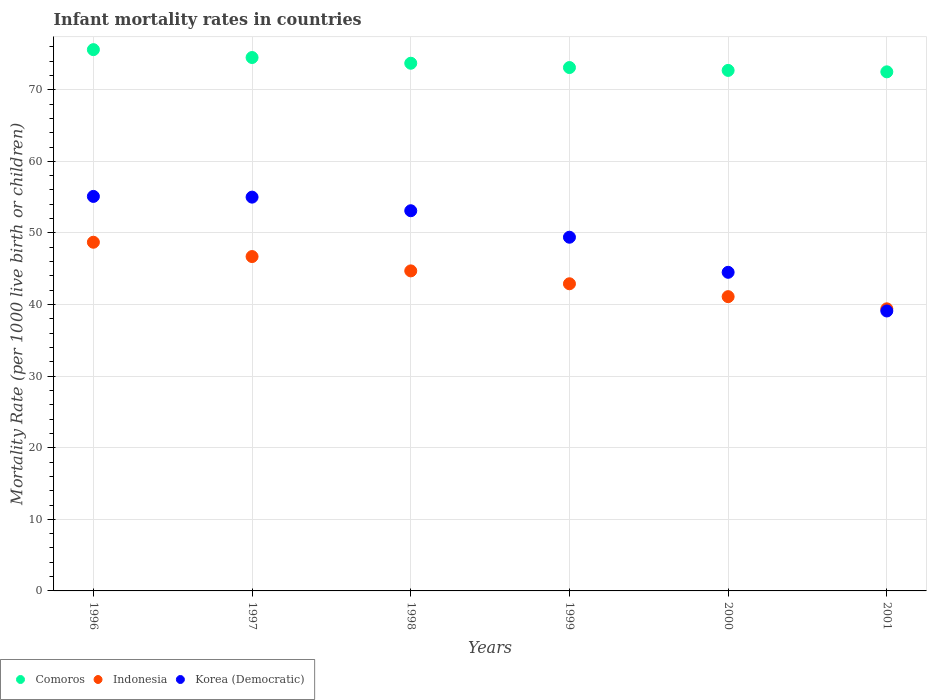What is the infant mortality rate in Korea (Democratic) in 1996?
Offer a very short reply. 55.1. Across all years, what is the maximum infant mortality rate in Korea (Democratic)?
Your answer should be compact. 55.1. Across all years, what is the minimum infant mortality rate in Comoros?
Give a very brief answer. 72.5. In which year was the infant mortality rate in Korea (Democratic) maximum?
Provide a succinct answer. 1996. In which year was the infant mortality rate in Comoros minimum?
Provide a succinct answer. 2001. What is the total infant mortality rate in Indonesia in the graph?
Give a very brief answer. 263.5. What is the difference between the infant mortality rate in Comoros in 1996 and that in 2001?
Your response must be concise. 3.1. What is the difference between the infant mortality rate in Korea (Democratic) in 1998 and the infant mortality rate in Indonesia in 2001?
Offer a terse response. 13.7. What is the average infant mortality rate in Comoros per year?
Provide a short and direct response. 73.68. In the year 1996, what is the difference between the infant mortality rate in Comoros and infant mortality rate in Indonesia?
Ensure brevity in your answer.  26.9. In how many years, is the infant mortality rate in Korea (Democratic) greater than 42?
Provide a succinct answer. 5. What is the ratio of the infant mortality rate in Indonesia in 1996 to that in 2000?
Provide a short and direct response. 1.18. Is the difference between the infant mortality rate in Comoros in 1998 and 2000 greater than the difference between the infant mortality rate in Indonesia in 1998 and 2000?
Offer a very short reply. No. What is the difference between the highest and the second highest infant mortality rate in Comoros?
Your answer should be compact. 1.1. What is the difference between the highest and the lowest infant mortality rate in Korea (Democratic)?
Offer a very short reply. 16. Is it the case that in every year, the sum of the infant mortality rate in Indonesia and infant mortality rate in Korea (Democratic)  is greater than the infant mortality rate in Comoros?
Keep it short and to the point. Yes. Does the infant mortality rate in Korea (Democratic) monotonically increase over the years?
Ensure brevity in your answer.  No. Is the infant mortality rate in Indonesia strictly greater than the infant mortality rate in Comoros over the years?
Provide a short and direct response. No. How many dotlines are there?
Offer a terse response. 3. Does the graph contain grids?
Your response must be concise. Yes. Where does the legend appear in the graph?
Provide a succinct answer. Bottom left. How many legend labels are there?
Give a very brief answer. 3. How are the legend labels stacked?
Provide a succinct answer. Horizontal. What is the title of the graph?
Give a very brief answer. Infant mortality rates in countries. What is the label or title of the X-axis?
Your answer should be compact. Years. What is the label or title of the Y-axis?
Offer a very short reply. Mortality Rate (per 1000 live birth or children). What is the Mortality Rate (per 1000 live birth or children) of Comoros in 1996?
Offer a terse response. 75.6. What is the Mortality Rate (per 1000 live birth or children) of Indonesia in 1996?
Ensure brevity in your answer.  48.7. What is the Mortality Rate (per 1000 live birth or children) of Korea (Democratic) in 1996?
Provide a succinct answer. 55.1. What is the Mortality Rate (per 1000 live birth or children) in Comoros in 1997?
Offer a terse response. 74.5. What is the Mortality Rate (per 1000 live birth or children) in Indonesia in 1997?
Provide a succinct answer. 46.7. What is the Mortality Rate (per 1000 live birth or children) in Comoros in 1998?
Offer a terse response. 73.7. What is the Mortality Rate (per 1000 live birth or children) of Indonesia in 1998?
Your answer should be compact. 44.7. What is the Mortality Rate (per 1000 live birth or children) of Korea (Democratic) in 1998?
Offer a very short reply. 53.1. What is the Mortality Rate (per 1000 live birth or children) of Comoros in 1999?
Provide a short and direct response. 73.1. What is the Mortality Rate (per 1000 live birth or children) of Indonesia in 1999?
Provide a short and direct response. 42.9. What is the Mortality Rate (per 1000 live birth or children) in Korea (Democratic) in 1999?
Give a very brief answer. 49.4. What is the Mortality Rate (per 1000 live birth or children) of Comoros in 2000?
Provide a short and direct response. 72.7. What is the Mortality Rate (per 1000 live birth or children) of Indonesia in 2000?
Your answer should be compact. 41.1. What is the Mortality Rate (per 1000 live birth or children) in Korea (Democratic) in 2000?
Your response must be concise. 44.5. What is the Mortality Rate (per 1000 live birth or children) in Comoros in 2001?
Keep it short and to the point. 72.5. What is the Mortality Rate (per 1000 live birth or children) in Indonesia in 2001?
Provide a short and direct response. 39.4. What is the Mortality Rate (per 1000 live birth or children) in Korea (Democratic) in 2001?
Make the answer very short. 39.1. Across all years, what is the maximum Mortality Rate (per 1000 live birth or children) in Comoros?
Provide a succinct answer. 75.6. Across all years, what is the maximum Mortality Rate (per 1000 live birth or children) in Indonesia?
Your response must be concise. 48.7. Across all years, what is the maximum Mortality Rate (per 1000 live birth or children) in Korea (Democratic)?
Keep it short and to the point. 55.1. Across all years, what is the minimum Mortality Rate (per 1000 live birth or children) in Comoros?
Keep it short and to the point. 72.5. Across all years, what is the minimum Mortality Rate (per 1000 live birth or children) in Indonesia?
Offer a terse response. 39.4. Across all years, what is the minimum Mortality Rate (per 1000 live birth or children) in Korea (Democratic)?
Offer a terse response. 39.1. What is the total Mortality Rate (per 1000 live birth or children) of Comoros in the graph?
Your answer should be very brief. 442.1. What is the total Mortality Rate (per 1000 live birth or children) in Indonesia in the graph?
Ensure brevity in your answer.  263.5. What is the total Mortality Rate (per 1000 live birth or children) in Korea (Democratic) in the graph?
Offer a very short reply. 296.2. What is the difference between the Mortality Rate (per 1000 live birth or children) of Indonesia in 1996 and that in 1997?
Make the answer very short. 2. What is the difference between the Mortality Rate (per 1000 live birth or children) in Comoros in 1996 and that in 1998?
Give a very brief answer. 1.9. What is the difference between the Mortality Rate (per 1000 live birth or children) of Indonesia in 1996 and that in 1999?
Offer a terse response. 5.8. What is the difference between the Mortality Rate (per 1000 live birth or children) of Comoros in 1996 and that in 2001?
Your response must be concise. 3.1. What is the difference between the Mortality Rate (per 1000 live birth or children) of Indonesia in 1996 and that in 2001?
Ensure brevity in your answer.  9.3. What is the difference between the Mortality Rate (per 1000 live birth or children) in Korea (Democratic) in 1996 and that in 2001?
Ensure brevity in your answer.  16. What is the difference between the Mortality Rate (per 1000 live birth or children) in Indonesia in 1997 and that in 1998?
Your answer should be compact. 2. What is the difference between the Mortality Rate (per 1000 live birth or children) in Korea (Democratic) in 1997 and that in 1998?
Your answer should be very brief. 1.9. What is the difference between the Mortality Rate (per 1000 live birth or children) of Comoros in 1997 and that in 1999?
Offer a very short reply. 1.4. What is the difference between the Mortality Rate (per 1000 live birth or children) in Indonesia in 1997 and that in 1999?
Offer a terse response. 3.8. What is the difference between the Mortality Rate (per 1000 live birth or children) of Comoros in 1997 and that in 2000?
Provide a succinct answer. 1.8. What is the difference between the Mortality Rate (per 1000 live birth or children) of Korea (Democratic) in 1997 and that in 2000?
Make the answer very short. 10.5. What is the difference between the Mortality Rate (per 1000 live birth or children) in Korea (Democratic) in 1997 and that in 2001?
Offer a terse response. 15.9. What is the difference between the Mortality Rate (per 1000 live birth or children) of Comoros in 1998 and that in 2000?
Provide a short and direct response. 1. What is the difference between the Mortality Rate (per 1000 live birth or children) in Indonesia in 1998 and that in 2000?
Provide a short and direct response. 3.6. What is the difference between the Mortality Rate (per 1000 live birth or children) of Korea (Democratic) in 1998 and that in 2000?
Your answer should be very brief. 8.6. What is the difference between the Mortality Rate (per 1000 live birth or children) in Indonesia in 1998 and that in 2001?
Ensure brevity in your answer.  5.3. What is the difference between the Mortality Rate (per 1000 live birth or children) in Comoros in 1999 and that in 2000?
Your response must be concise. 0.4. What is the difference between the Mortality Rate (per 1000 live birth or children) of Comoros in 1999 and that in 2001?
Keep it short and to the point. 0.6. What is the difference between the Mortality Rate (per 1000 live birth or children) in Indonesia in 1999 and that in 2001?
Ensure brevity in your answer.  3.5. What is the difference between the Mortality Rate (per 1000 live birth or children) of Korea (Democratic) in 1999 and that in 2001?
Make the answer very short. 10.3. What is the difference between the Mortality Rate (per 1000 live birth or children) of Comoros in 1996 and the Mortality Rate (per 1000 live birth or children) of Indonesia in 1997?
Keep it short and to the point. 28.9. What is the difference between the Mortality Rate (per 1000 live birth or children) of Comoros in 1996 and the Mortality Rate (per 1000 live birth or children) of Korea (Democratic) in 1997?
Offer a terse response. 20.6. What is the difference between the Mortality Rate (per 1000 live birth or children) in Indonesia in 1996 and the Mortality Rate (per 1000 live birth or children) in Korea (Democratic) in 1997?
Your answer should be very brief. -6.3. What is the difference between the Mortality Rate (per 1000 live birth or children) of Comoros in 1996 and the Mortality Rate (per 1000 live birth or children) of Indonesia in 1998?
Your answer should be very brief. 30.9. What is the difference between the Mortality Rate (per 1000 live birth or children) in Comoros in 1996 and the Mortality Rate (per 1000 live birth or children) in Korea (Democratic) in 1998?
Provide a short and direct response. 22.5. What is the difference between the Mortality Rate (per 1000 live birth or children) in Comoros in 1996 and the Mortality Rate (per 1000 live birth or children) in Indonesia in 1999?
Ensure brevity in your answer.  32.7. What is the difference between the Mortality Rate (per 1000 live birth or children) in Comoros in 1996 and the Mortality Rate (per 1000 live birth or children) in Korea (Democratic) in 1999?
Provide a succinct answer. 26.2. What is the difference between the Mortality Rate (per 1000 live birth or children) of Comoros in 1996 and the Mortality Rate (per 1000 live birth or children) of Indonesia in 2000?
Your answer should be very brief. 34.5. What is the difference between the Mortality Rate (per 1000 live birth or children) of Comoros in 1996 and the Mortality Rate (per 1000 live birth or children) of Korea (Democratic) in 2000?
Offer a very short reply. 31.1. What is the difference between the Mortality Rate (per 1000 live birth or children) in Indonesia in 1996 and the Mortality Rate (per 1000 live birth or children) in Korea (Democratic) in 2000?
Give a very brief answer. 4.2. What is the difference between the Mortality Rate (per 1000 live birth or children) of Comoros in 1996 and the Mortality Rate (per 1000 live birth or children) of Indonesia in 2001?
Make the answer very short. 36.2. What is the difference between the Mortality Rate (per 1000 live birth or children) of Comoros in 1996 and the Mortality Rate (per 1000 live birth or children) of Korea (Democratic) in 2001?
Ensure brevity in your answer.  36.5. What is the difference between the Mortality Rate (per 1000 live birth or children) of Indonesia in 1996 and the Mortality Rate (per 1000 live birth or children) of Korea (Democratic) in 2001?
Ensure brevity in your answer.  9.6. What is the difference between the Mortality Rate (per 1000 live birth or children) of Comoros in 1997 and the Mortality Rate (per 1000 live birth or children) of Indonesia in 1998?
Your answer should be compact. 29.8. What is the difference between the Mortality Rate (per 1000 live birth or children) of Comoros in 1997 and the Mortality Rate (per 1000 live birth or children) of Korea (Democratic) in 1998?
Give a very brief answer. 21.4. What is the difference between the Mortality Rate (per 1000 live birth or children) of Indonesia in 1997 and the Mortality Rate (per 1000 live birth or children) of Korea (Democratic) in 1998?
Provide a short and direct response. -6.4. What is the difference between the Mortality Rate (per 1000 live birth or children) in Comoros in 1997 and the Mortality Rate (per 1000 live birth or children) in Indonesia in 1999?
Ensure brevity in your answer.  31.6. What is the difference between the Mortality Rate (per 1000 live birth or children) of Comoros in 1997 and the Mortality Rate (per 1000 live birth or children) of Korea (Democratic) in 1999?
Provide a short and direct response. 25.1. What is the difference between the Mortality Rate (per 1000 live birth or children) of Comoros in 1997 and the Mortality Rate (per 1000 live birth or children) of Indonesia in 2000?
Make the answer very short. 33.4. What is the difference between the Mortality Rate (per 1000 live birth or children) of Comoros in 1997 and the Mortality Rate (per 1000 live birth or children) of Korea (Democratic) in 2000?
Your answer should be very brief. 30. What is the difference between the Mortality Rate (per 1000 live birth or children) in Comoros in 1997 and the Mortality Rate (per 1000 live birth or children) in Indonesia in 2001?
Your answer should be compact. 35.1. What is the difference between the Mortality Rate (per 1000 live birth or children) in Comoros in 1997 and the Mortality Rate (per 1000 live birth or children) in Korea (Democratic) in 2001?
Your answer should be very brief. 35.4. What is the difference between the Mortality Rate (per 1000 live birth or children) of Comoros in 1998 and the Mortality Rate (per 1000 live birth or children) of Indonesia in 1999?
Provide a short and direct response. 30.8. What is the difference between the Mortality Rate (per 1000 live birth or children) in Comoros in 1998 and the Mortality Rate (per 1000 live birth or children) in Korea (Democratic) in 1999?
Your response must be concise. 24.3. What is the difference between the Mortality Rate (per 1000 live birth or children) in Comoros in 1998 and the Mortality Rate (per 1000 live birth or children) in Indonesia in 2000?
Offer a terse response. 32.6. What is the difference between the Mortality Rate (per 1000 live birth or children) in Comoros in 1998 and the Mortality Rate (per 1000 live birth or children) in Korea (Democratic) in 2000?
Offer a very short reply. 29.2. What is the difference between the Mortality Rate (per 1000 live birth or children) of Comoros in 1998 and the Mortality Rate (per 1000 live birth or children) of Indonesia in 2001?
Your response must be concise. 34.3. What is the difference between the Mortality Rate (per 1000 live birth or children) in Comoros in 1998 and the Mortality Rate (per 1000 live birth or children) in Korea (Democratic) in 2001?
Give a very brief answer. 34.6. What is the difference between the Mortality Rate (per 1000 live birth or children) of Indonesia in 1998 and the Mortality Rate (per 1000 live birth or children) of Korea (Democratic) in 2001?
Offer a terse response. 5.6. What is the difference between the Mortality Rate (per 1000 live birth or children) of Comoros in 1999 and the Mortality Rate (per 1000 live birth or children) of Indonesia in 2000?
Give a very brief answer. 32. What is the difference between the Mortality Rate (per 1000 live birth or children) of Comoros in 1999 and the Mortality Rate (per 1000 live birth or children) of Korea (Democratic) in 2000?
Provide a short and direct response. 28.6. What is the difference between the Mortality Rate (per 1000 live birth or children) in Indonesia in 1999 and the Mortality Rate (per 1000 live birth or children) in Korea (Democratic) in 2000?
Your answer should be compact. -1.6. What is the difference between the Mortality Rate (per 1000 live birth or children) in Comoros in 1999 and the Mortality Rate (per 1000 live birth or children) in Indonesia in 2001?
Provide a short and direct response. 33.7. What is the difference between the Mortality Rate (per 1000 live birth or children) in Comoros in 2000 and the Mortality Rate (per 1000 live birth or children) in Indonesia in 2001?
Your answer should be compact. 33.3. What is the difference between the Mortality Rate (per 1000 live birth or children) of Comoros in 2000 and the Mortality Rate (per 1000 live birth or children) of Korea (Democratic) in 2001?
Provide a succinct answer. 33.6. What is the difference between the Mortality Rate (per 1000 live birth or children) of Indonesia in 2000 and the Mortality Rate (per 1000 live birth or children) of Korea (Democratic) in 2001?
Offer a very short reply. 2. What is the average Mortality Rate (per 1000 live birth or children) of Comoros per year?
Offer a terse response. 73.68. What is the average Mortality Rate (per 1000 live birth or children) in Indonesia per year?
Provide a short and direct response. 43.92. What is the average Mortality Rate (per 1000 live birth or children) in Korea (Democratic) per year?
Make the answer very short. 49.37. In the year 1996, what is the difference between the Mortality Rate (per 1000 live birth or children) of Comoros and Mortality Rate (per 1000 live birth or children) of Indonesia?
Provide a succinct answer. 26.9. In the year 1997, what is the difference between the Mortality Rate (per 1000 live birth or children) in Comoros and Mortality Rate (per 1000 live birth or children) in Indonesia?
Provide a short and direct response. 27.8. In the year 1997, what is the difference between the Mortality Rate (per 1000 live birth or children) in Comoros and Mortality Rate (per 1000 live birth or children) in Korea (Democratic)?
Make the answer very short. 19.5. In the year 1997, what is the difference between the Mortality Rate (per 1000 live birth or children) in Indonesia and Mortality Rate (per 1000 live birth or children) in Korea (Democratic)?
Offer a terse response. -8.3. In the year 1998, what is the difference between the Mortality Rate (per 1000 live birth or children) in Comoros and Mortality Rate (per 1000 live birth or children) in Korea (Democratic)?
Provide a short and direct response. 20.6. In the year 1999, what is the difference between the Mortality Rate (per 1000 live birth or children) of Comoros and Mortality Rate (per 1000 live birth or children) of Indonesia?
Ensure brevity in your answer.  30.2. In the year 1999, what is the difference between the Mortality Rate (per 1000 live birth or children) in Comoros and Mortality Rate (per 1000 live birth or children) in Korea (Democratic)?
Offer a terse response. 23.7. In the year 1999, what is the difference between the Mortality Rate (per 1000 live birth or children) in Indonesia and Mortality Rate (per 1000 live birth or children) in Korea (Democratic)?
Your response must be concise. -6.5. In the year 2000, what is the difference between the Mortality Rate (per 1000 live birth or children) of Comoros and Mortality Rate (per 1000 live birth or children) of Indonesia?
Your response must be concise. 31.6. In the year 2000, what is the difference between the Mortality Rate (per 1000 live birth or children) in Comoros and Mortality Rate (per 1000 live birth or children) in Korea (Democratic)?
Make the answer very short. 28.2. In the year 2000, what is the difference between the Mortality Rate (per 1000 live birth or children) of Indonesia and Mortality Rate (per 1000 live birth or children) of Korea (Democratic)?
Offer a very short reply. -3.4. In the year 2001, what is the difference between the Mortality Rate (per 1000 live birth or children) in Comoros and Mortality Rate (per 1000 live birth or children) in Indonesia?
Offer a terse response. 33.1. In the year 2001, what is the difference between the Mortality Rate (per 1000 live birth or children) of Comoros and Mortality Rate (per 1000 live birth or children) of Korea (Democratic)?
Make the answer very short. 33.4. What is the ratio of the Mortality Rate (per 1000 live birth or children) of Comoros in 1996 to that in 1997?
Your answer should be very brief. 1.01. What is the ratio of the Mortality Rate (per 1000 live birth or children) of Indonesia in 1996 to that in 1997?
Your answer should be very brief. 1.04. What is the ratio of the Mortality Rate (per 1000 live birth or children) in Comoros in 1996 to that in 1998?
Your response must be concise. 1.03. What is the ratio of the Mortality Rate (per 1000 live birth or children) in Indonesia in 1996 to that in 1998?
Provide a short and direct response. 1.09. What is the ratio of the Mortality Rate (per 1000 live birth or children) in Korea (Democratic) in 1996 to that in 1998?
Offer a very short reply. 1.04. What is the ratio of the Mortality Rate (per 1000 live birth or children) of Comoros in 1996 to that in 1999?
Keep it short and to the point. 1.03. What is the ratio of the Mortality Rate (per 1000 live birth or children) of Indonesia in 1996 to that in 1999?
Provide a succinct answer. 1.14. What is the ratio of the Mortality Rate (per 1000 live birth or children) in Korea (Democratic) in 1996 to that in 1999?
Your answer should be compact. 1.12. What is the ratio of the Mortality Rate (per 1000 live birth or children) in Comoros in 1996 to that in 2000?
Your response must be concise. 1.04. What is the ratio of the Mortality Rate (per 1000 live birth or children) of Indonesia in 1996 to that in 2000?
Your answer should be compact. 1.18. What is the ratio of the Mortality Rate (per 1000 live birth or children) of Korea (Democratic) in 1996 to that in 2000?
Your response must be concise. 1.24. What is the ratio of the Mortality Rate (per 1000 live birth or children) of Comoros in 1996 to that in 2001?
Provide a short and direct response. 1.04. What is the ratio of the Mortality Rate (per 1000 live birth or children) in Indonesia in 1996 to that in 2001?
Your answer should be very brief. 1.24. What is the ratio of the Mortality Rate (per 1000 live birth or children) of Korea (Democratic) in 1996 to that in 2001?
Provide a succinct answer. 1.41. What is the ratio of the Mortality Rate (per 1000 live birth or children) in Comoros in 1997 to that in 1998?
Keep it short and to the point. 1.01. What is the ratio of the Mortality Rate (per 1000 live birth or children) in Indonesia in 1997 to that in 1998?
Your answer should be very brief. 1.04. What is the ratio of the Mortality Rate (per 1000 live birth or children) of Korea (Democratic) in 1997 to that in 1998?
Offer a terse response. 1.04. What is the ratio of the Mortality Rate (per 1000 live birth or children) in Comoros in 1997 to that in 1999?
Provide a succinct answer. 1.02. What is the ratio of the Mortality Rate (per 1000 live birth or children) in Indonesia in 1997 to that in 1999?
Ensure brevity in your answer.  1.09. What is the ratio of the Mortality Rate (per 1000 live birth or children) of Korea (Democratic) in 1997 to that in 1999?
Provide a short and direct response. 1.11. What is the ratio of the Mortality Rate (per 1000 live birth or children) in Comoros in 1997 to that in 2000?
Offer a very short reply. 1.02. What is the ratio of the Mortality Rate (per 1000 live birth or children) in Indonesia in 1997 to that in 2000?
Your answer should be very brief. 1.14. What is the ratio of the Mortality Rate (per 1000 live birth or children) in Korea (Democratic) in 1997 to that in 2000?
Keep it short and to the point. 1.24. What is the ratio of the Mortality Rate (per 1000 live birth or children) of Comoros in 1997 to that in 2001?
Provide a short and direct response. 1.03. What is the ratio of the Mortality Rate (per 1000 live birth or children) in Indonesia in 1997 to that in 2001?
Your response must be concise. 1.19. What is the ratio of the Mortality Rate (per 1000 live birth or children) in Korea (Democratic) in 1997 to that in 2001?
Provide a succinct answer. 1.41. What is the ratio of the Mortality Rate (per 1000 live birth or children) in Comoros in 1998 to that in 1999?
Make the answer very short. 1.01. What is the ratio of the Mortality Rate (per 1000 live birth or children) of Indonesia in 1998 to that in 1999?
Offer a very short reply. 1.04. What is the ratio of the Mortality Rate (per 1000 live birth or children) of Korea (Democratic) in 1998 to that in 1999?
Your answer should be compact. 1.07. What is the ratio of the Mortality Rate (per 1000 live birth or children) in Comoros in 1998 to that in 2000?
Your answer should be very brief. 1.01. What is the ratio of the Mortality Rate (per 1000 live birth or children) of Indonesia in 1998 to that in 2000?
Give a very brief answer. 1.09. What is the ratio of the Mortality Rate (per 1000 live birth or children) in Korea (Democratic) in 1998 to that in 2000?
Your answer should be compact. 1.19. What is the ratio of the Mortality Rate (per 1000 live birth or children) of Comoros in 1998 to that in 2001?
Your answer should be very brief. 1.02. What is the ratio of the Mortality Rate (per 1000 live birth or children) in Indonesia in 1998 to that in 2001?
Offer a terse response. 1.13. What is the ratio of the Mortality Rate (per 1000 live birth or children) in Korea (Democratic) in 1998 to that in 2001?
Keep it short and to the point. 1.36. What is the ratio of the Mortality Rate (per 1000 live birth or children) in Indonesia in 1999 to that in 2000?
Offer a very short reply. 1.04. What is the ratio of the Mortality Rate (per 1000 live birth or children) of Korea (Democratic) in 1999 to that in 2000?
Offer a terse response. 1.11. What is the ratio of the Mortality Rate (per 1000 live birth or children) of Comoros in 1999 to that in 2001?
Make the answer very short. 1.01. What is the ratio of the Mortality Rate (per 1000 live birth or children) of Indonesia in 1999 to that in 2001?
Your answer should be very brief. 1.09. What is the ratio of the Mortality Rate (per 1000 live birth or children) in Korea (Democratic) in 1999 to that in 2001?
Your response must be concise. 1.26. What is the ratio of the Mortality Rate (per 1000 live birth or children) of Indonesia in 2000 to that in 2001?
Your response must be concise. 1.04. What is the ratio of the Mortality Rate (per 1000 live birth or children) in Korea (Democratic) in 2000 to that in 2001?
Make the answer very short. 1.14. What is the difference between the highest and the second highest Mortality Rate (per 1000 live birth or children) of Comoros?
Your response must be concise. 1.1. What is the difference between the highest and the second highest Mortality Rate (per 1000 live birth or children) in Indonesia?
Provide a short and direct response. 2. What is the difference between the highest and the lowest Mortality Rate (per 1000 live birth or children) of Comoros?
Ensure brevity in your answer.  3.1. 